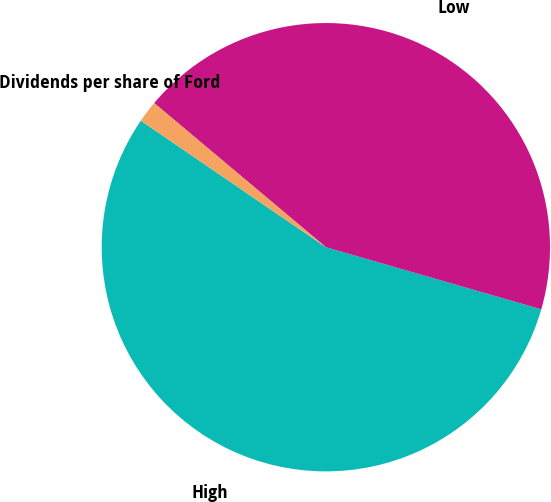Convert chart. <chart><loc_0><loc_0><loc_500><loc_500><pie_chart><fcel>High<fcel>Low<fcel>Dividends per share of Ford<nl><fcel>55.07%<fcel>43.35%<fcel>1.57%<nl></chart> 